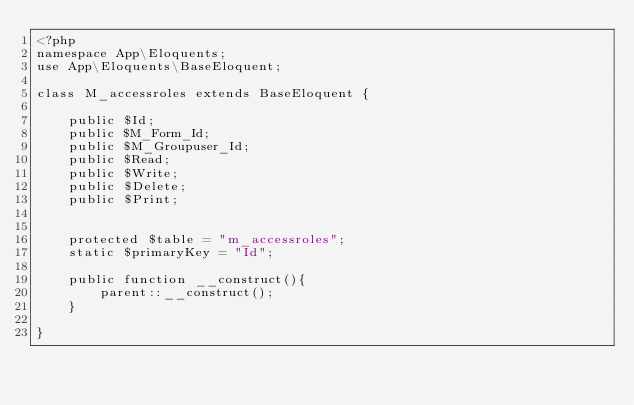Convert code to text. <code><loc_0><loc_0><loc_500><loc_500><_PHP_><?php  
namespace App\Eloquents;
use App\Eloquents\BaseEloquent;

class M_accessroles extends BaseEloquent {

    public $Id;
    public $M_Form_Id;
    public $M_Groupuser_Id;
    public $Read;
    public $Write;
    public $Delete;
    public $Print;

    
    protected $table = "m_accessroles";
    static $primaryKey = "Id";

    public function __construct(){
        parent::__construct();
    }

}</code> 